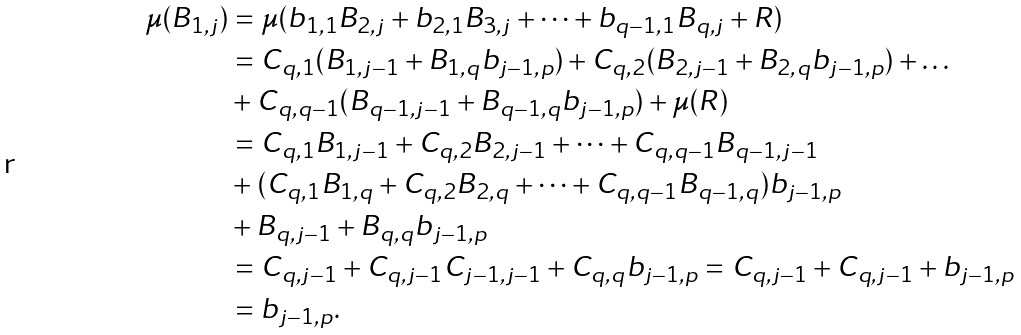<formula> <loc_0><loc_0><loc_500><loc_500>\mu ( B _ { 1 , j } ) & = \mu ( b _ { 1 , 1 } B _ { 2 , j } + b _ { 2 , 1 } B _ { 3 , j } + \dots + b _ { q - 1 , 1 } B _ { q , j } + R ) \\ & = C _ { q , 1 } ( B _ { 1 , j - 1 } + B _ { 1 , q } b _ { j - 1 , p } ) + C _ { q , 2 } ( B _ { 2 , j - 1 } + B _ { 2 , q } b _ { j - 1 , p } ) + \dots \\ & + C _ { q , q - 1 } ( B _ { q - 1 , j - 1 } + B _ { q - 1 , q } b _ { j - 1 , p } ) + \mu ( R ) \\ & = C _ { q , 1 } B _ { 1 , j - 1 } + C _ { q , 2 } B _ { 2 , j - 1 } + \dots + C _ { q , q - 1 } B _ { q - 1 , j - 1 } \\ & + ( C _ { q , 1 } B _ { 1 , q } + C _ { q , 2 } B _ { 2 , q } + \dots + C _ { q , q - 1 } B _ { q - 1 , q } ) b _ { j - 1 , p } \\ & + B _ { q , j - 1 } + B _ { q , q } b _ { j - 1 , p } \\ & = C _ { q , j - 1 } + C _ { q , j - 1 } C _ { j - 1 , j - 1 } + C _ { q , q } b _ { j - 1 , p } = C _ { q , j - 1 } + C _ { q , j - 1 } + b _ { j - 1 , p } \\ & = b _ { j - 1 , p } .</formula> 